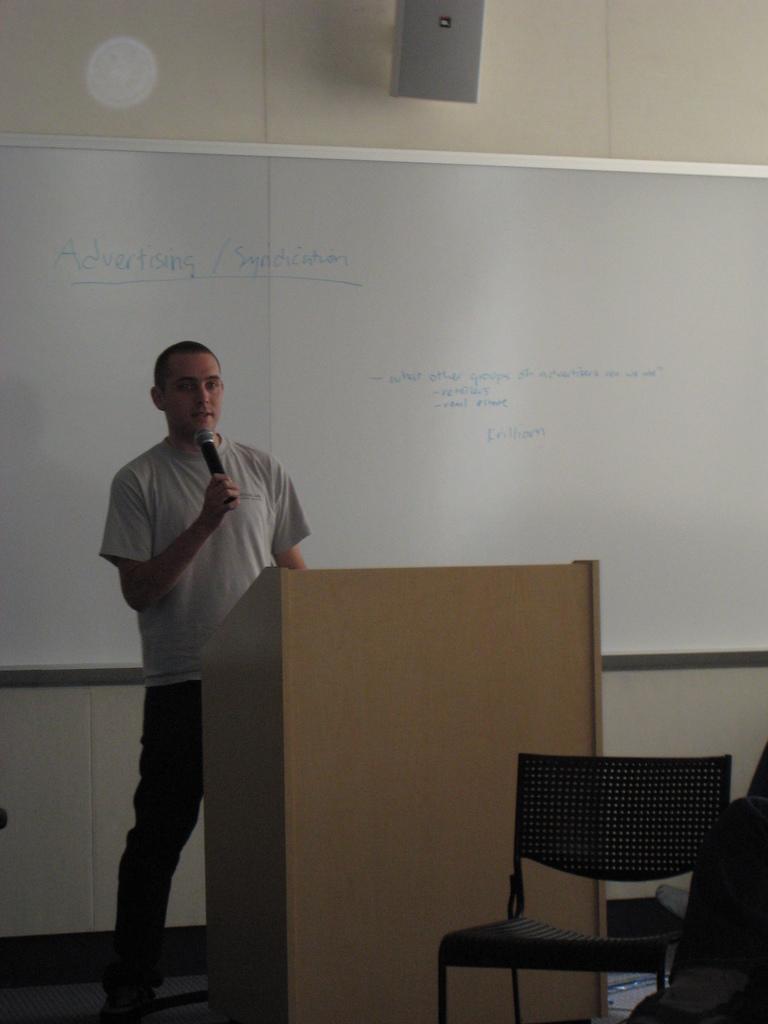Please provide a concise description of this image. This picture shows a man standing at a podium and speaking with the help of a microphone in his hand and we see a chair and a white board on the wall. 